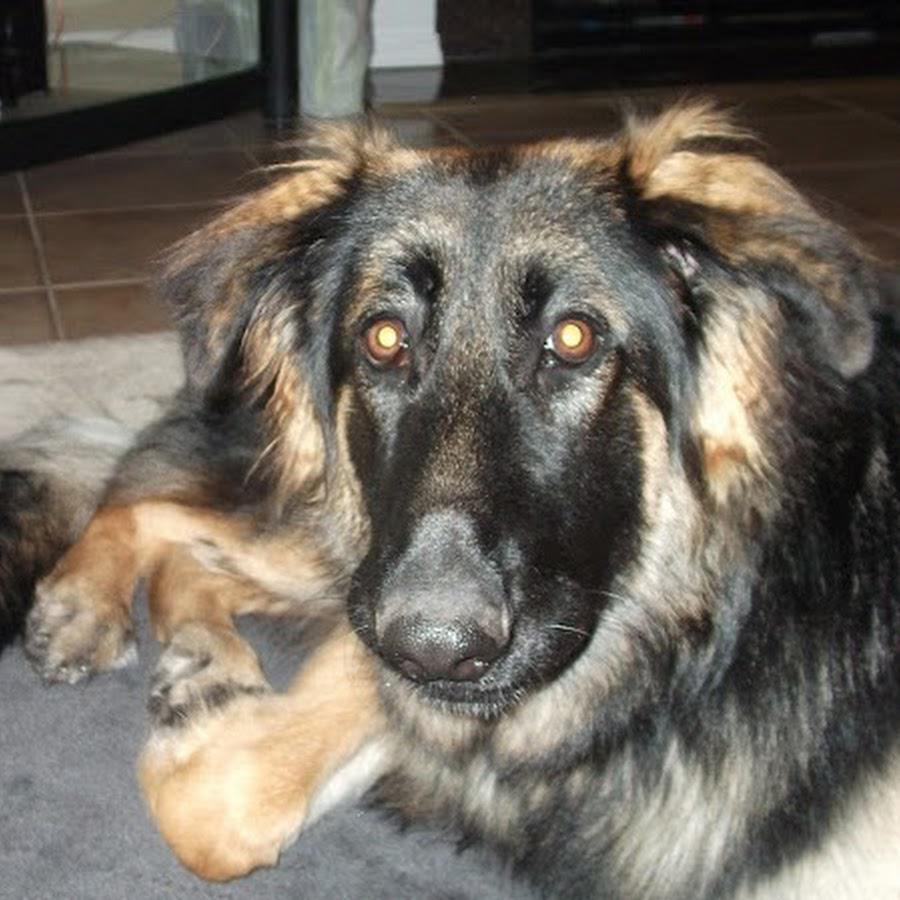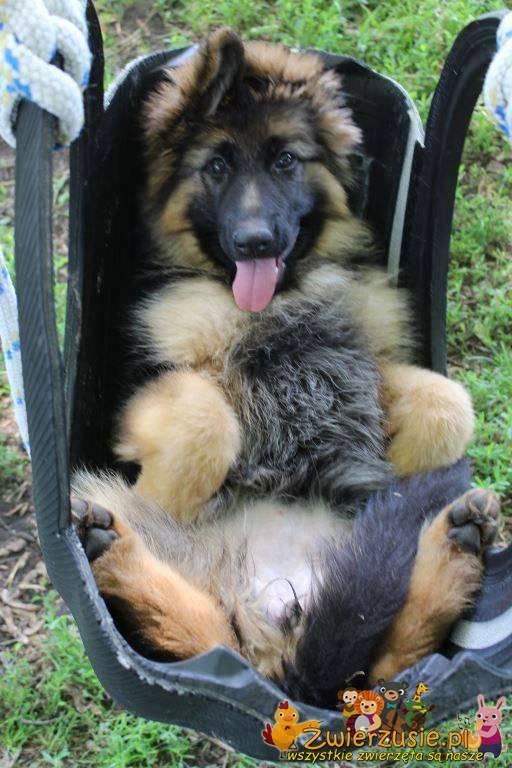The first image is the image on the left, the second image is the image on the right. For the images shown, is this caption "There is a woman with a large dog in the image on the left" true? Answer yes or no. No. The first image is the image on the left, the second image is the image on the right. Assess this claim about the two images: "Two large dogs have black faces and their mouths open.". Correct or not? Answer yes or no. No. 